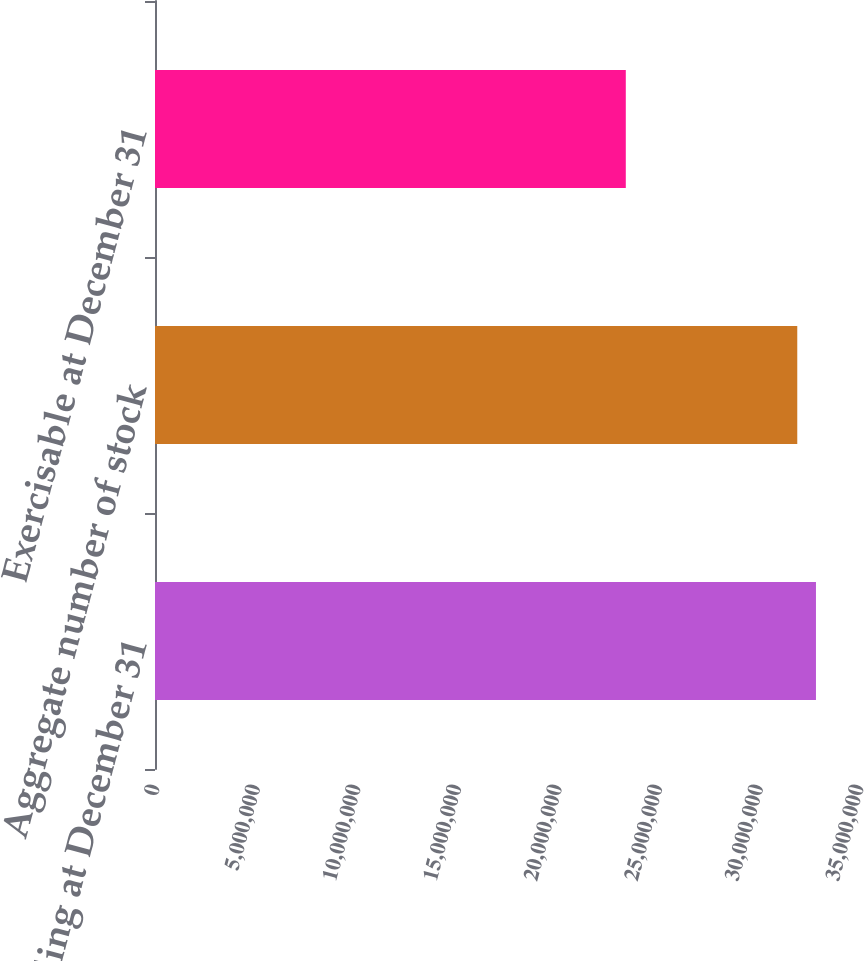<chart> <loc_0><loc_0><loc_500><loc_500><bar_chart><fcel>Outstanding at December 31<fcel>Aggregate number of stock<fcel>Exercisable at December 31<nl><fcel>3.28606e+07<fcel>3.1931e+07<fcel>2.3406e+07<nl></chart> 